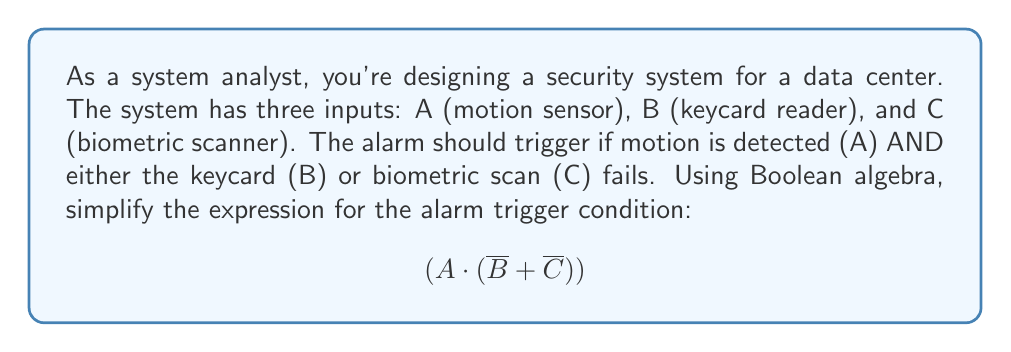Could you help me with this problem? Let's simplify this expression step-by-step using Boolean algebra laws:

1) Start with the given expression:
   $$(A \cdot (\overline{B} + \overline{C}))$$

2) Apply the distributive law:
   $$A \cdot \overline{B} + A \cdot \overline{C}$$

3) This is already in its simplest form, known as the sum-of-products (SOP) form.

4) We can verify this using a truth table:

   | A | B | C | $\overline{B}$ | $\overline{C}$ | $\overline{B} + \overline{C}$ | $A \cdot (\overline{B} + \overline{C})$ | $A \cdot \overline{B} + A \cdot \overline{C}$ |
   |---|---|---|----------------|----------------|------------------------------|------------------------------------------|---------------------------------------------|
   | 0 | 0 | 0 | 1              | 1              | 1                            | 0                                        | 0                                           |
   | 0 | 0 | 1 | 1              | 0              | 1                            | 0                                        | 0                                           |
   | 0 | 1 | 0 | 0              | 1              | 1                            | 0                                        | 0                                           |
   | 0 | 1 | 1 | 0              | 0              | 0                            | 0                                        | 0                                           |
   | 1 | 0 | 0 | 1              | 1              | 1                            | 1                                        | 1                                           |
   | 1 | 0 | 1 | 1              | 0              | 1                            | 1                                        | 1                                           |
   | 1 | 1 | 0 | 0              | 1              | 1                            | 1                                        | 1                                           |
   | 1 | 1 | 1 | 0              | 0              | 0                            | 0                                        | 0                                           |

5) The truth table confirms that both expressions are equivalent.

This simplified form directly translates to the system's logic: the alarm triggers when there's motion (A) AND either the keycard fails (A · $\overline{B}$) or the biometric scan fails (A · $\overline{C}$).
Answer: $$A \cdot \overline{B} + A \cdot \overline{C}$$ 